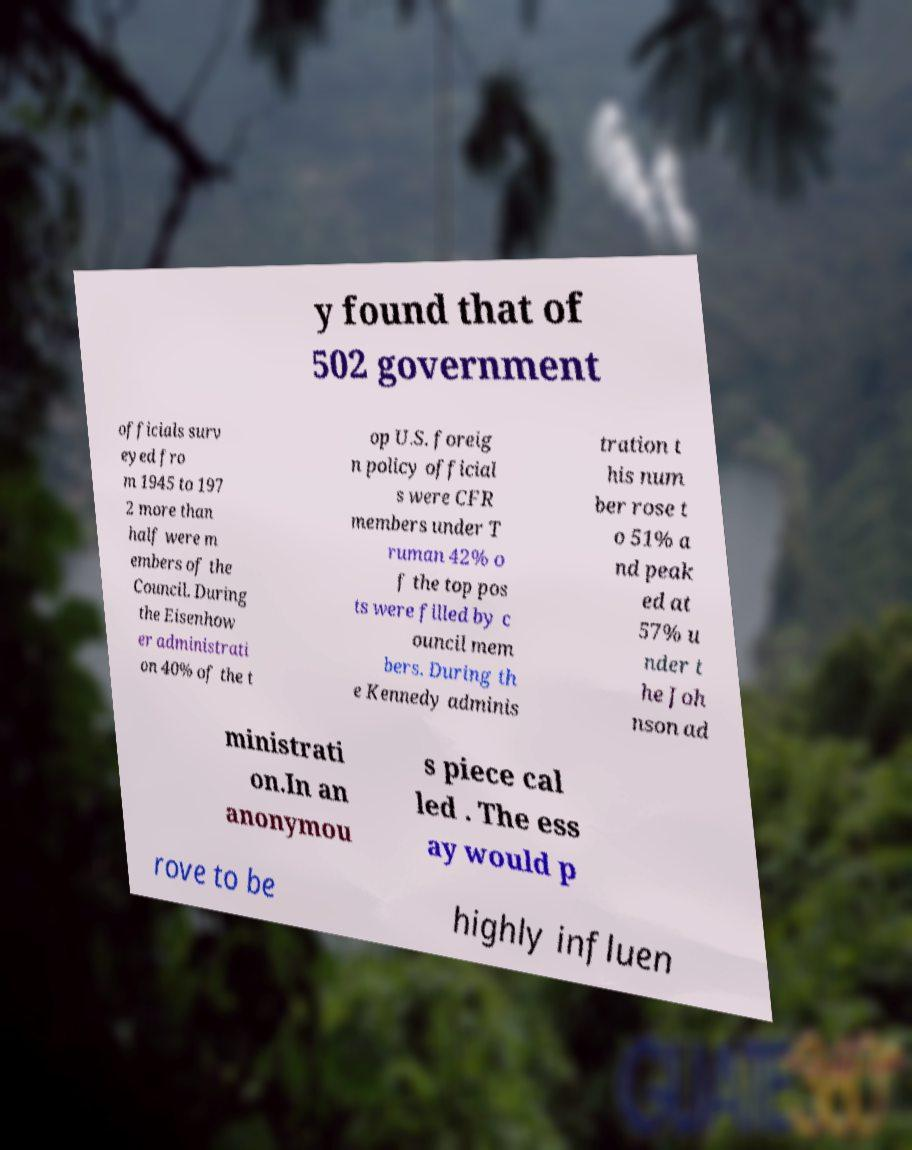Can you read and provide the text displayed in the image?This photo seems to have some interesting text. Can you extract and type it out for me? y found that of 502 government officials surv eyed fro m 1945 to 197 2 more than half were m embers of the Council. During the Eisenhow er administrati on 40% of the t op U.S. foreig n policy official s were CFR members under T ruman 42% o f the top pos ts were filled by c ouncil mem bers. During th e Kennedy adminis tration t his num ber rose t o 51% a nd peak ed at 57% u nder t he Joh nson ad ministrati on.In an anonymou s piece cal led . The ess ay would p rove to be highly influen 